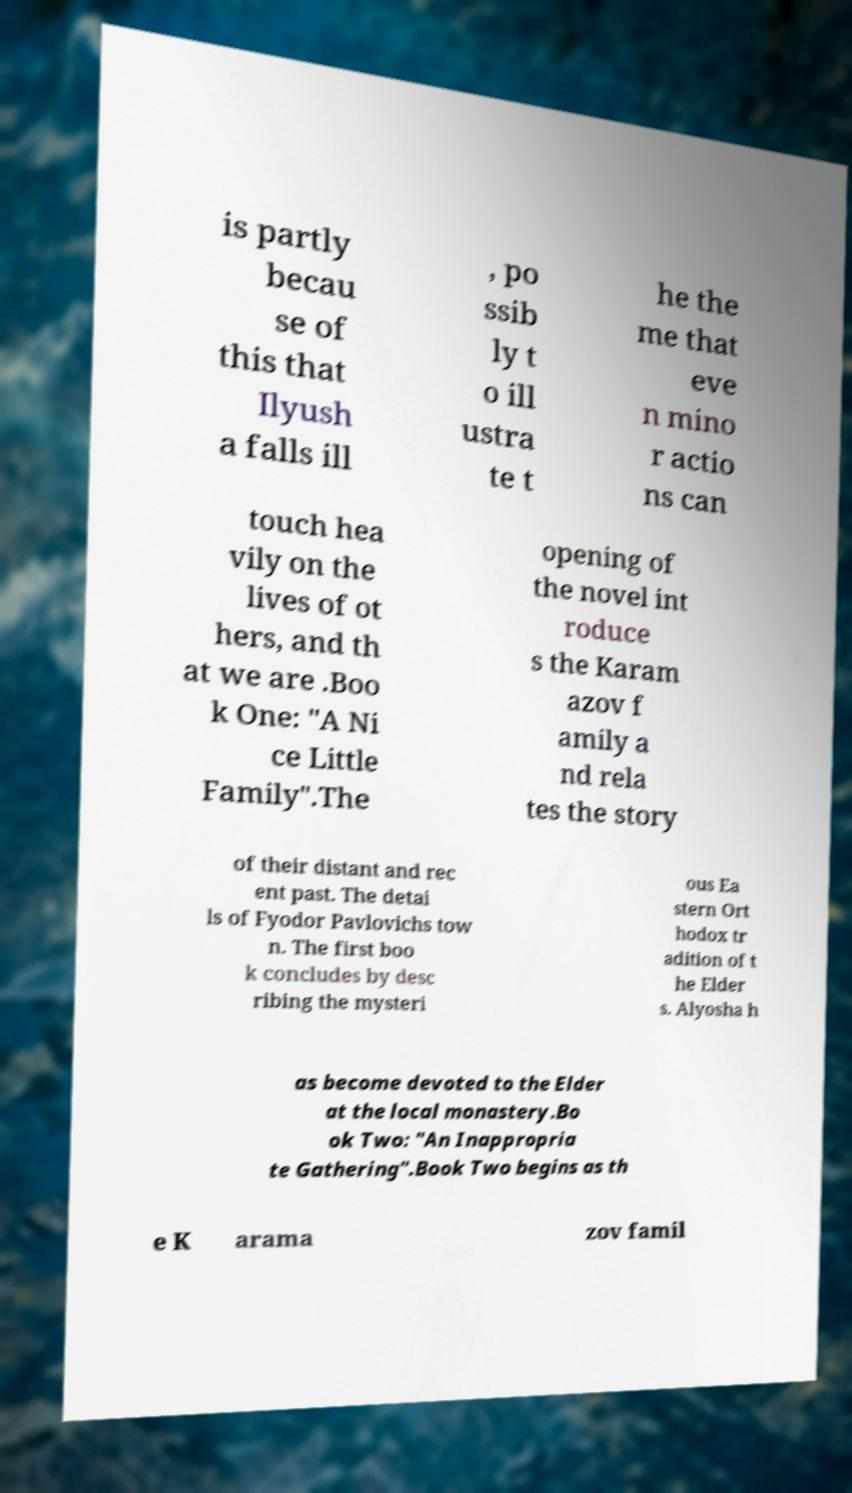Could you extract and type out the text from this image? is partly becau se of this that Ilyush a falls ill , po ssib ly t o ill ustra te t he the me that eve n mino r actio ns can touch hea vily on the lives of ot hers, and th at we are .Boo k One: "A Ni ce Little Family".The opening of the novel int roduce s the Karam azov f amily a nd rela tes the story of their distant and rec ent past. The detai ls of Fyodor Pavlovichs tow n. The first boo k concludes by desc ribing the mysteri ous Ea stern Ort hodox tr adition of t he Elder s. Alyosha h as become devoted to the Elder at the local monastery.Bo ok Two: "An Inappropria te Gathering".Book Two begins as th e K arama zov famil 